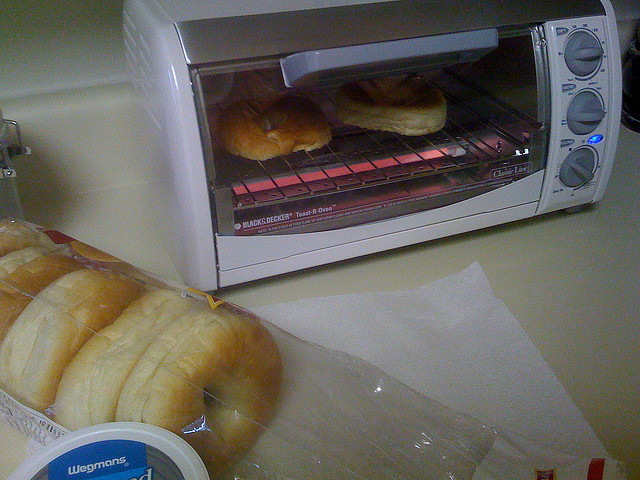Please transcribe the text information in this image. Wegmans d BLACK 6 DECKER Classic lier Toast-R-Over 